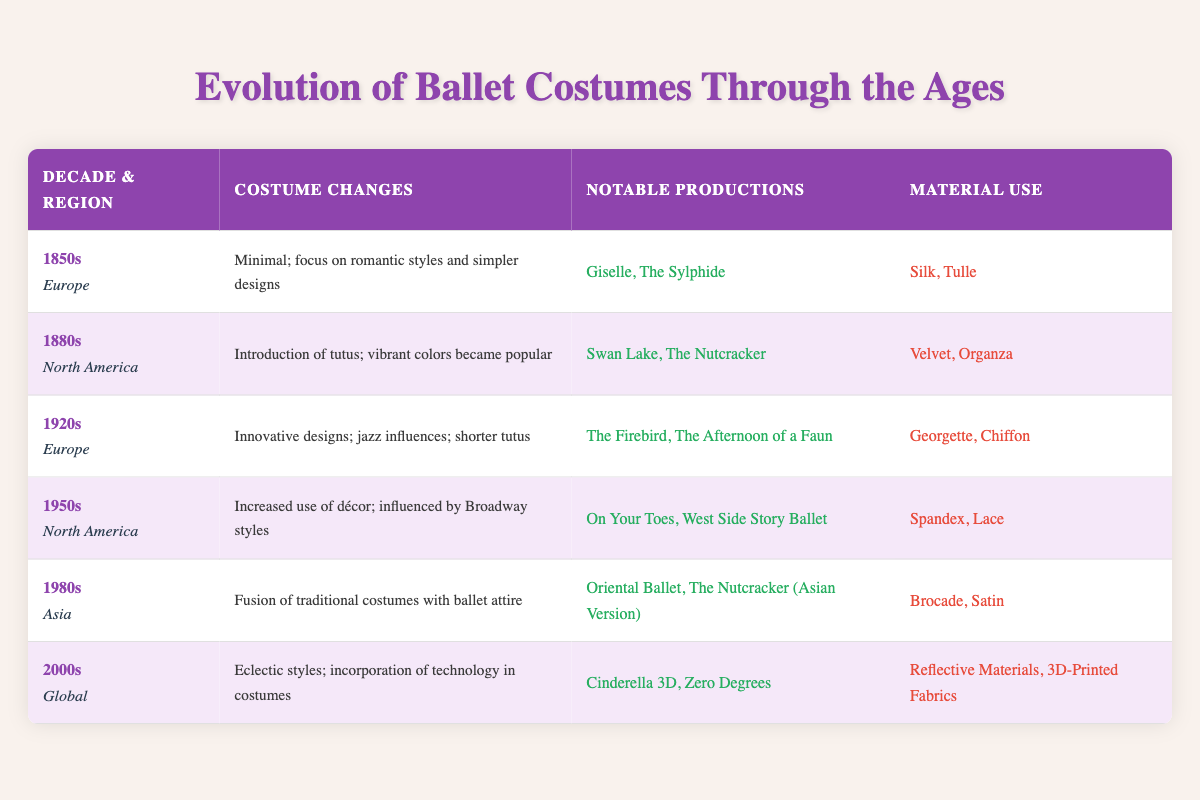What costume changes occurred in the 1880s in North America? According to the table, the costume changes in the 1880s in North America included the introduction of tutus and the popularity of vibrant colors.
Answer: Introduction of tutus; vibrant colors became popular Which materials were used for costumes in the 1950s North America? The table lists the material use for costumes in the 1950s North America as Spandex and Lace.
Answer: Spandex, Lace Were there any costume changes noted for the 2000s globally? Yes, the 2000s saw eclectic styles and the incorporation of technology in costumes, as mentioned in the table.
Answer: Yes What notable productions are associated with the 1920s in Europe? The table identifies "The Firebird" and "The Afternoon of a Faun" as the notable productions associated with the 1920s in Europe.
Answer: The Firebird, The Afternoon of a Faun In which decade did Asia see a fusion of traditional costumes with ballet attire? According to the table, Asia saw a fusion of traditional costumes with ballet attire in the 1980s.
Answer: 1980s What is the average decade mentioned in the table? The table presents five different decades: 1850s, 1880s, 1920s, 1950s, and 1980s. To find the average, we can determine the range they cover: from the 1850s to the 2000s; the middle decade within this range is the 1950s, as it is the midpoint in the chronological list.
Answer: 1950s How many regions are represented in the notable productions from the 2000s? The notable productions for the 2000s, as stated in the table, are "Cinderella 3D" and "Zero Degrees," and these productions are noted as global, indicating one overarching region that covers multiple cultures.
Answer: 1 Which materials were used in the 1920s in Europe? The table specifies that the materials used in the 1920s in Europe were Georgette and Chiffon.
Answer: Georgette, Chiffon Was there an increase in décor in costumes during the 1950s? Yes, the table indicates that there was an increased use of décor influenced by Broadway styles in the 1950s North America.
Answer: Yes 